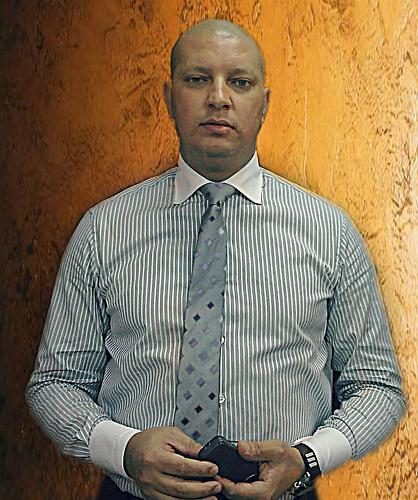Mention the object the man is wearing on his hands while holding a cell phone. The man is wearing a watch on his hands. What color is the man's tie and which object can you find on it? The man's tie is gray and has small purple diamonds on it. Evaluate the image's quality based on the given information. The image has a good detail of object positions and sizes, making it suitable for object detection tasks. Describe the background of the image in a few words. There is a wall behind the man. Provide a short description of the man's face features in the image. The man has visible eyes, nose, and left ear. Using complex reasoning, describe the most likely scenario taking place in the image. A man is attending an event or gathering, dressed with a gray tie that has small purple diamonds, using his cell phone, and wearing a watch on his hands. Identify the main subject interacting with a cell phone in the image. A man holding a cell phone. Analyze and describe the sentiment or mood portrayed by the man in the image. The man seems to be focused or engaged while holding the cell phone. How many small purple diamonds can you find on the man's tie? There are 10 small purple diamonds on the man's tie. What kind of objects and their interactions can you observe in this image? A man holding a cell phone and wearing a tie with small purple diamonds and a watch on his hands. Is the wall behind the man covered in bright graffiti? The original caption only mentions the presence of a wall, so adding extra and untrue details, like the presence of graffiti, is misleading. Is the diamond on the man's tie green and large? The original captions describe the diamonds as small and purple, so changing the color and size is misleading. Is the man holding the cell phone with his left hand? The original caption mentions a man holding a cell phone, but the right hand of the man is mentioned separately. Suggesting that the man is holding the phone with his left hand is misleading since the image's information implies the opposite. Does the man have blue eyes and a red nose? The original captions mention the eyes and nose of the man, but do not provide any information about their color. Assigning random colors to them is misleading. Is the cell phone being held by the man white and small? The original captions state that the cell phone is black and do not mention it being small, so this question contradicts the given information. Is the man wearing a gold watch on his right hand? The original captions state that the man has a watch on his hand, but they do not mention the color or the material. Claiming that the watch is gold, and placing it on the opposite hand, contradicts the given information. 